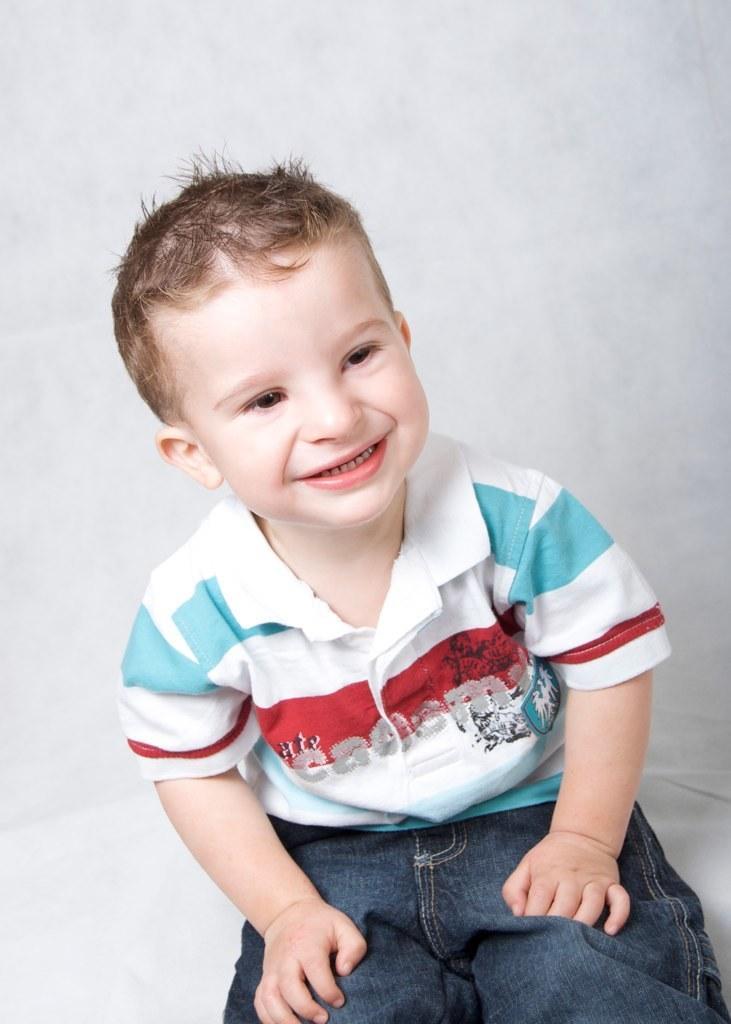In one or two sentences, can you explain what this image depicts? In this image we can see a boy smiling. 